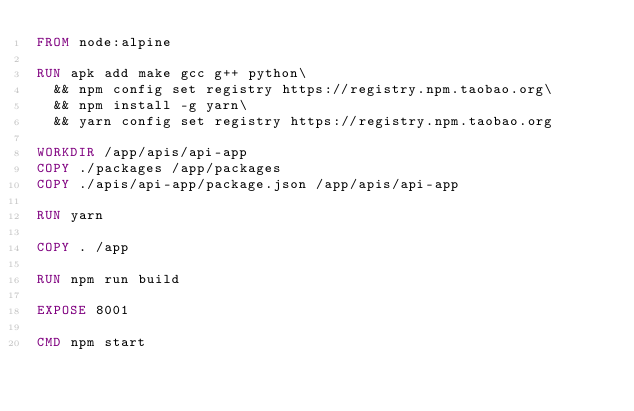Convert code to text. <code><loc_0><loc_0><loc_500><loc_500><_Dockerfile_>FROM node:alpine

RUN apk add make gcc g++ python\
  && npm config set registry https://registry.npm.taobao.org\
  && npm install -g yarn\
  && yarn config set registry https://registry.npm.taobao.org

WORKDIR /app/apis/api-app
COPY ./packages /app/packages
COPY ./apis/api-app/package.json /app/apis/api-app

RUN yarn

COPY . /app

RUN npm run build

EXPOSE 8001

CMD npm start
</code> 